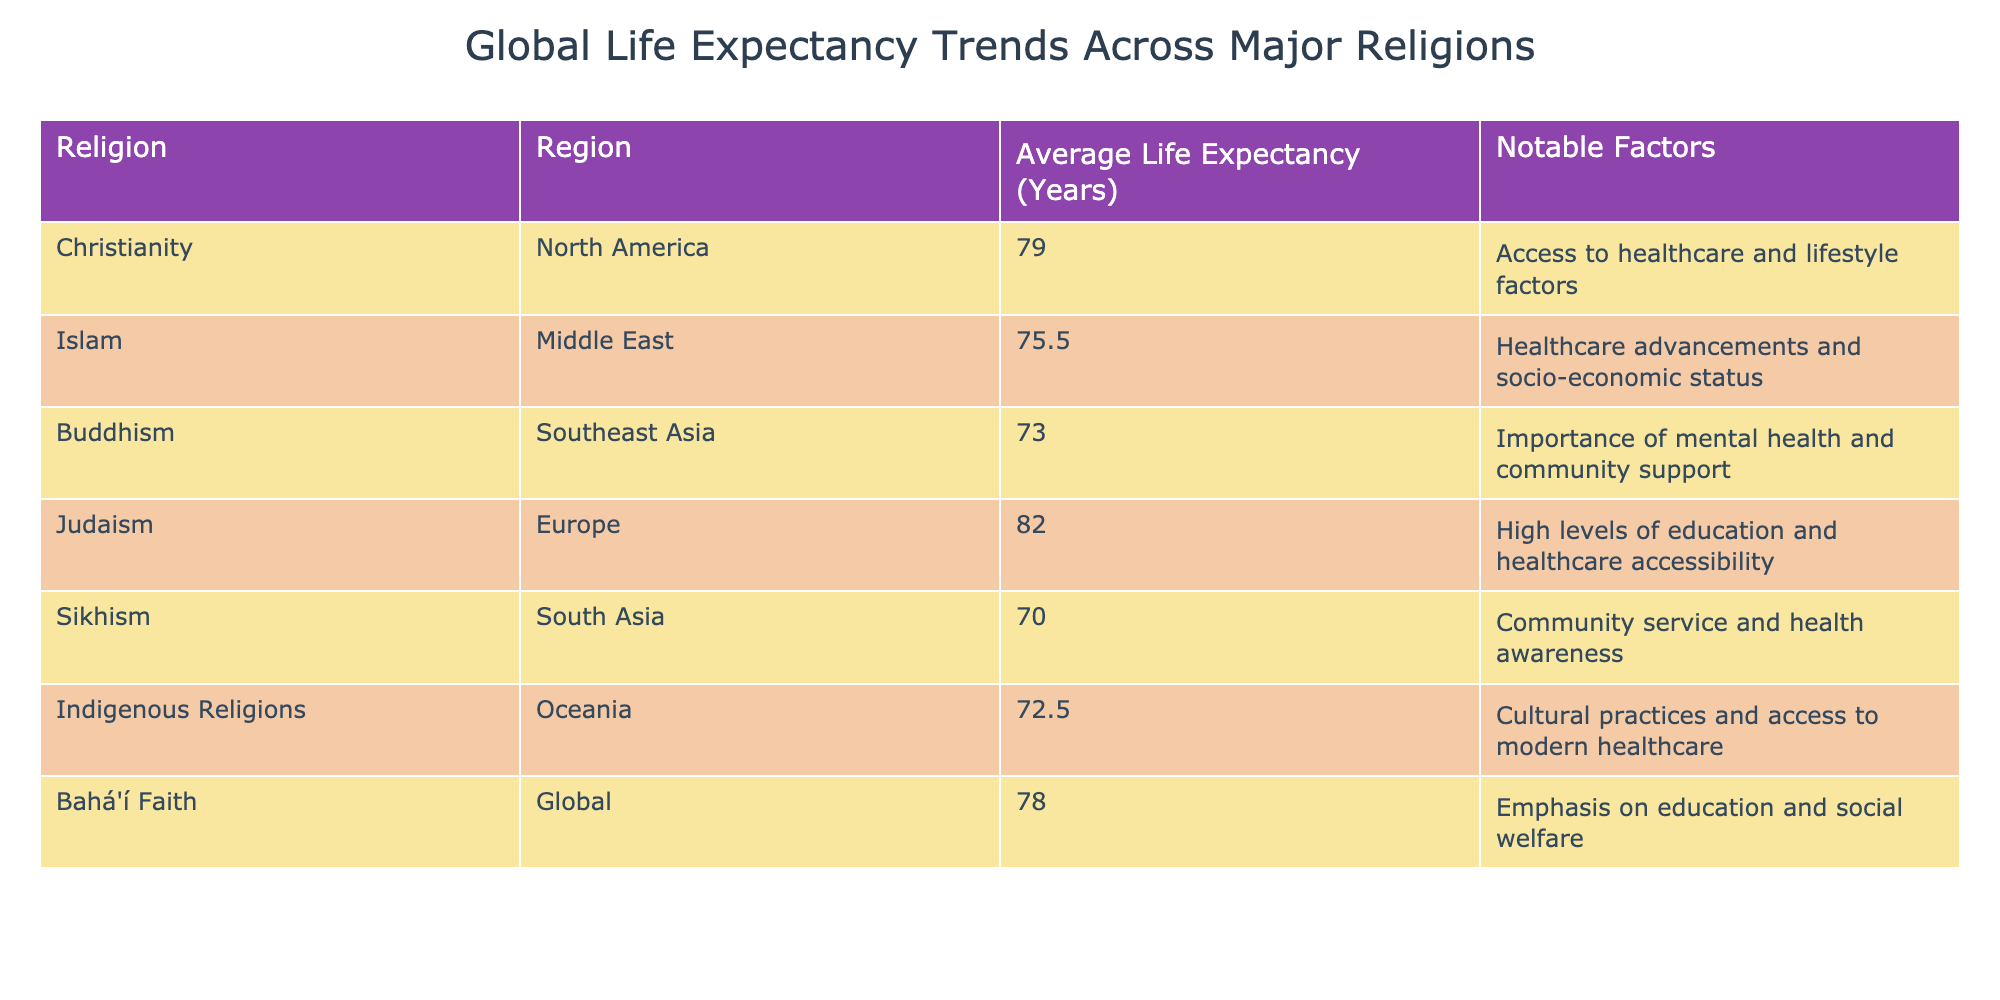What is the average life expectancy for followers of Judaism? The table shows that Judaism in Europe has an average life expectancy of 82.0 years. This value is directly from the table.
Answer: 82.0 Which religion has the lowest average life expectancy? According to the table, Sikhism in South Asia has the lowest average life expectancy at 70.0 years. This can be answered directly by comparing the values in the Average Life Expectancy column.
Answer: 70.0 What is the average life expectancy for religions in Southeast Asia? The relevant religion in Southeast Asia is Buddhism, which has an average life expectancy of 73.0 years. Since it's the only religion listed for that region, the answer is taken directly from that row.
Answer: 73.0 If we compare the average life expectancy of Christianity and Islam, what is the difference? Christianity has an average life expectancy of 79.0 years and Islam has 75.5 years. The difference can be calculated as 79.0 - 75.5 = 3.5 years. This requires subtracting the two values from the table.
Answer: 3.5 Is it true that the average life expectancy for followers of Bahá'í Faith is higher than that of Indigenous Religions? The average life expectancy for Bahá'í Faith is 78.0 years while for Indigenous Religions, it is 72.5 years. Since 78.0 is greater than 72.5, the statement is true. This involves a simple comparison of two values.
Answer: Yes What combination of life expectancy values results in an average of 75.0 years for the religions listed in South Asia? The average life expectancy for Sikhism in South Asia is 70.0 years. To find a value that would average to 75, we can consider that we need another value represented by an additional religion. Since only Sikhism is accounted, we cannot achieve that with just one data point but averaging two specific values can help us see that 80.0 years could potentially average with 70.0 years to 75.0. Here it illustrates complex reasoning of finding conditions that yield a specific average.
Answer: 75.0 Which religion regions show a notable emphasis on community support? The table indicates Buddhism (Southeast Asia) with community support and Sikhism (South Asia) with health awareness, both of which emphasize community in their notable factors. The answer lies in identifying rows with an emphasis on community.
Answer: Buddhism and Sikhism What is the average life expectancy across all listed religions? To find the average, we sum the life expectancies of all religions: 79.0 (Christianity) + 75.5 (Islam) + 73.0 (Buddhism) + 82.0 (Judaism) + 70.0 (Sikhism) + 72.5 (Indigenous Religions) + 78.0 (Bahá'í Faith) = 530.0. There are 7 data points, so we divide by 7, resulting in 76.57 years. This averages data across all religions according to their values.
Answer: 76.57 